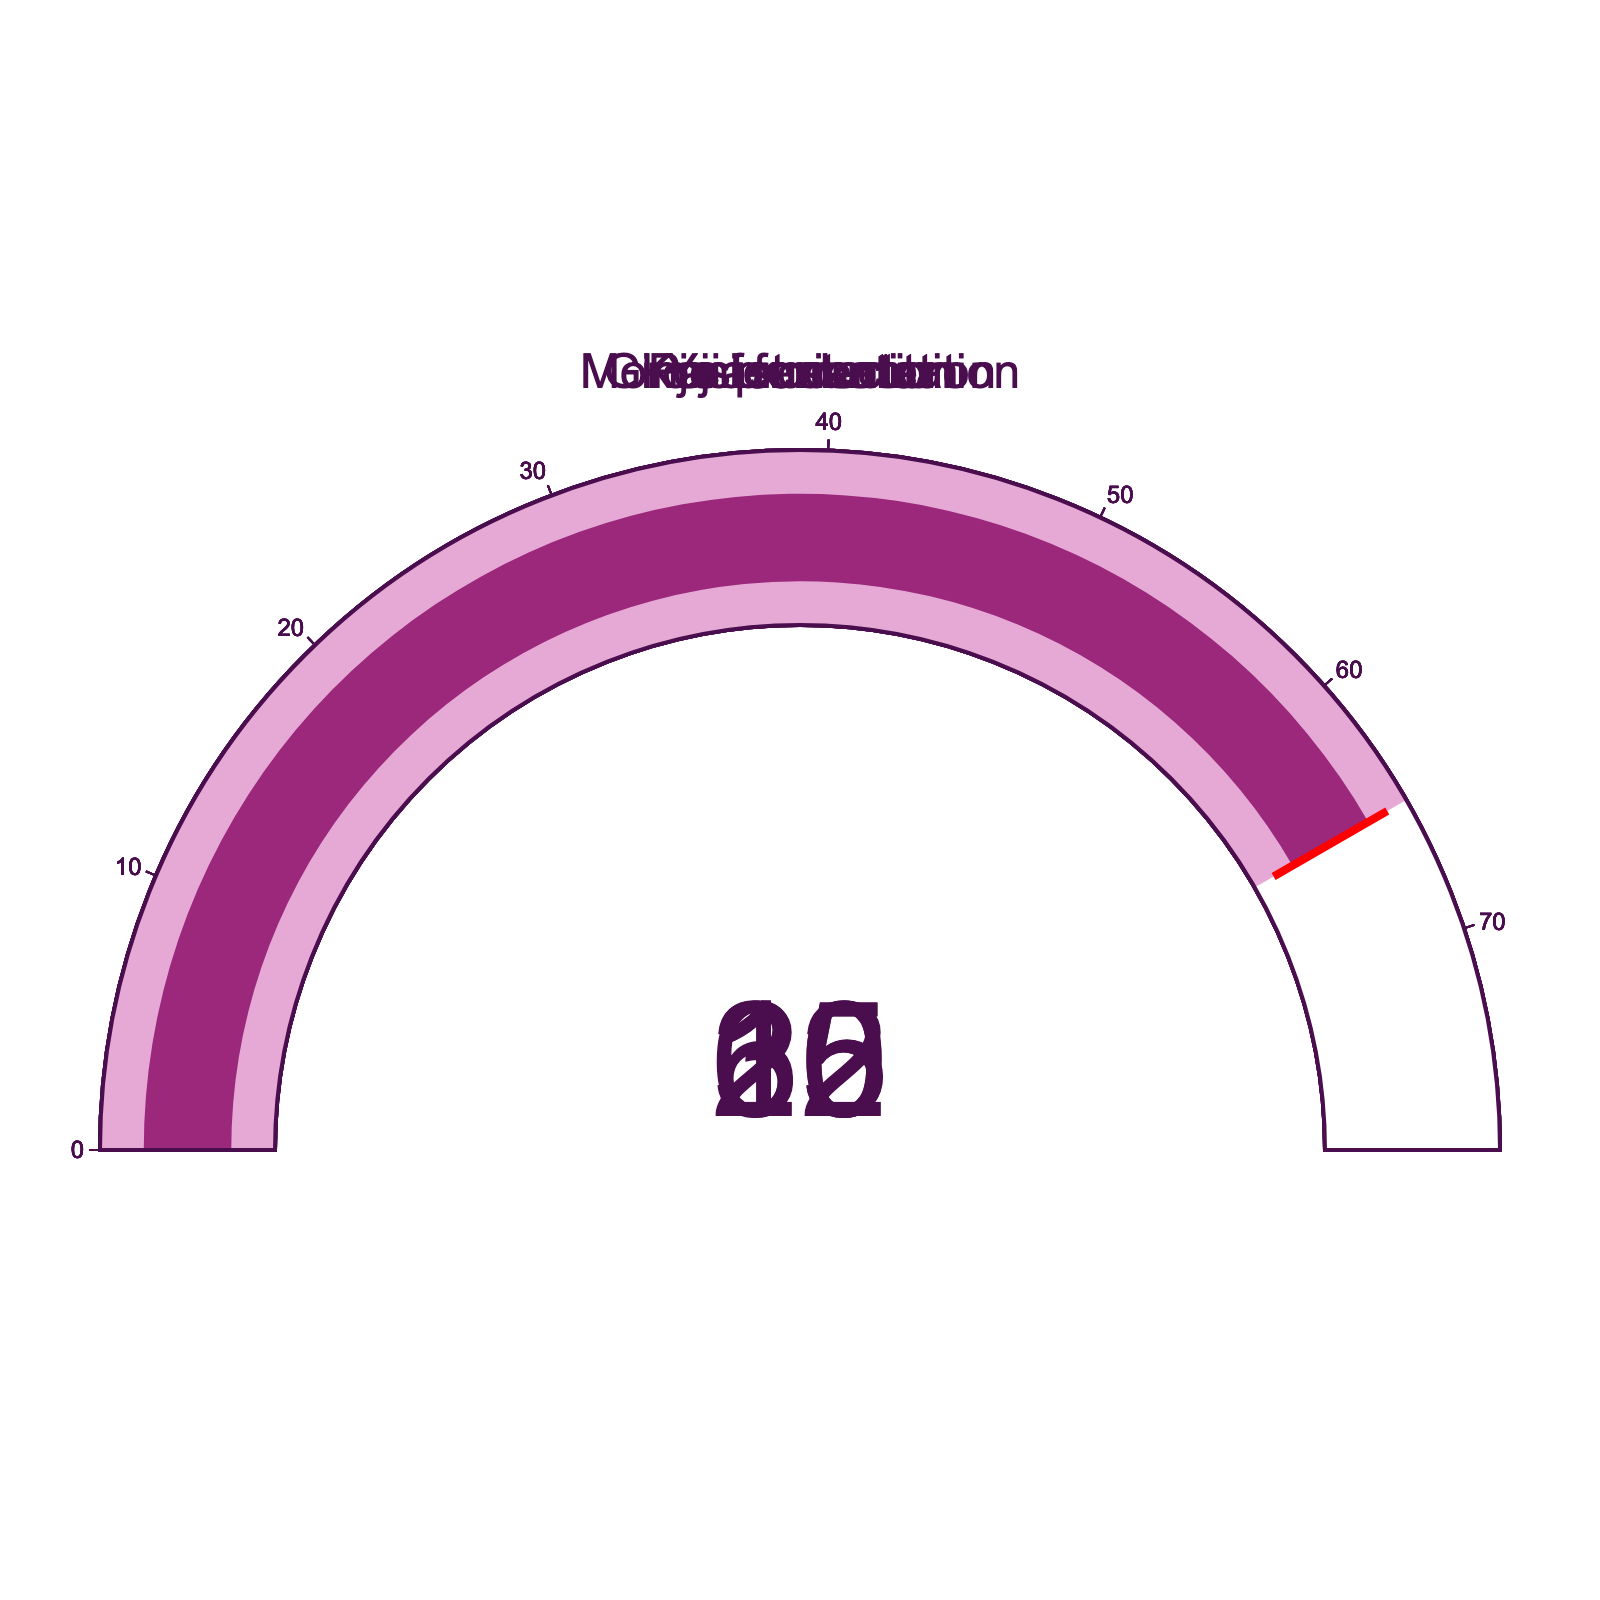What is the optimal temperature for Moromi fermentation? The figure shows a gauge indicating the temperature value for Moromi fermentation. Referring to the gauge, the value is 15°C.
Answer: 15°C What is the optimal temperature for Ginjo fermentation? The figure has a separate gauge for each fermentation stage. The one labeled Ginjo fermentation shows a value of 10°C.
Answer: 10°C Which fermentation process requires the highest temperature? By comparing the temperatures on the different gauges, Koji production has the highest temperature of 30°C.
Answer: Koji production What is the temperature difference between Yeast starter and Moromi fermentation? Referring to the gauges for Yeast starter (22°C) and Moromi fermentation (15°C), the difference is calculated as 22 - 15.
Answer: 7°C Which fermentation process has the lowest optimal temperature, and what is it? Among the gauges, Ginjo fermentation has the lowest optimal temperature of 10°C.
Answer: Ginjo fermentation, 10°C What is the mean of the temperatures of all fermentation processes listed? Sum the temperatures (15 + 30 + 22 + 10 + 65 = 142) and divide by the number of processes (5) to find the mean: 142 / 5.
Answer: 28.4°C How much higher is the temperature for Koji production compared to Pasteurization? Compare the values given for Koji production (30°C) and Pasteurization (65°C). Subtract the temperatures: 65 - 30.
Answer: 35°C How much higher is the Pasteurization temperature than the average temperature of the other stages? Calculate the average temperature of the stages except for Pasteurization (15 + 30 + 22 + 10 = 77, then 77 / 4 = 19.25) and compare it to Pasteurization (65), 65 - 19.25.
Answer: 45.75°C 